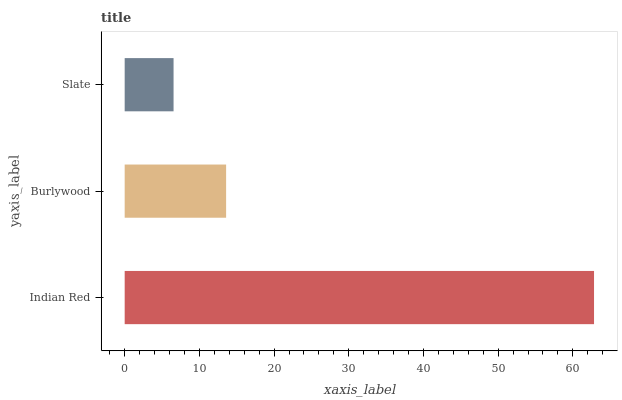Is Slate the minimum?
Answer yes or no. Yes. Is Indian Red the maximum?
Answer yes or no. Yes. Is Burlywood the minimum?
Answer yes or no. No. Is Burlywood the maximum?
Answer yes or no. No. Is Indian Red greater than Burlywood?
Answer yes or no. Yes. Is Burlywood less than Indian Red?
Answer yes or no. Yes. Is Burlywood greater than Indian Red?
Answer yes or no. No. Is Indian Red less than Burlywood?
Answer yes or no. No. Is Burlywood the high median?
Answer yes or no. Yes. Is Burlywood the low median?
Answer yes or no. Yes. Is Indian Red the high median?
Answer yes or no. No. Is Indian Red the low median?
Answer yes or no. No. 